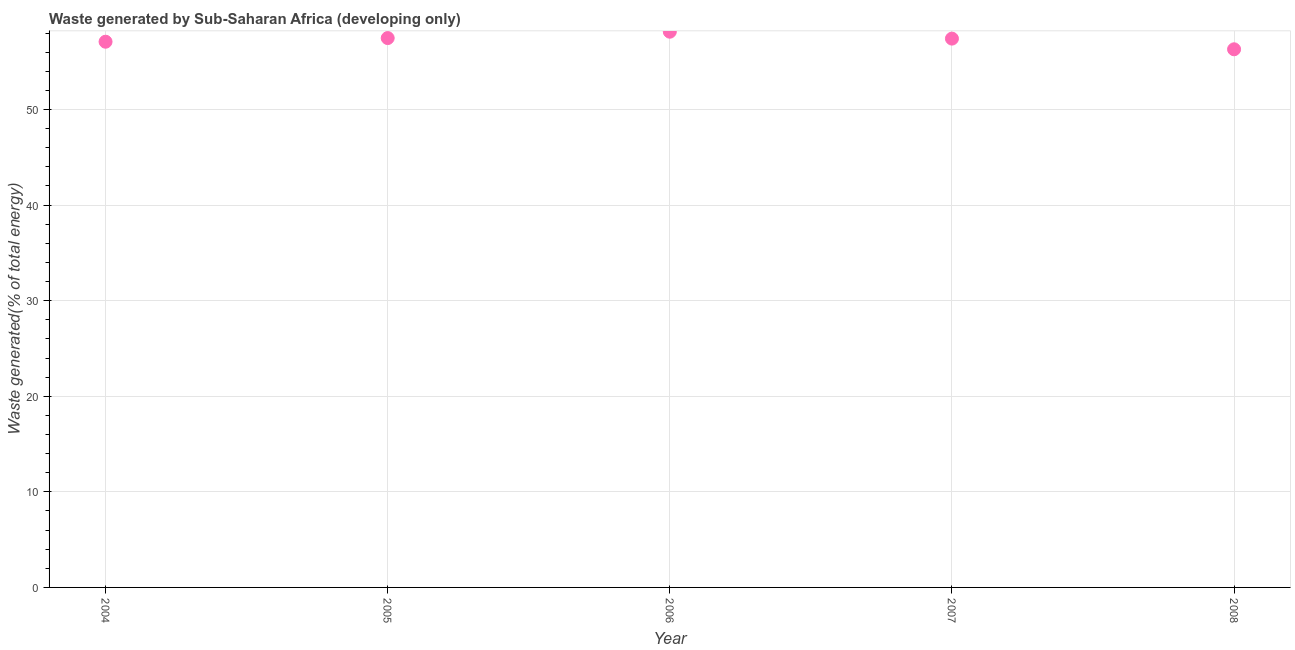What is the amount of waste generated in 2007?
Keep it short and to the point. 57.41. Across all years, what is the maximum amount of waste generated?
Offer a terse response. 58.14. Across all years, what is the minimum amount of waste generated?
Ensure brevity in your answer.  56.3. In which year was the amount of waste generated minimum?
Keep it short and to the point. 2008. What is the sum of the amount of waste generated?
Offer a very short reply. 286.41. What is the difference between the amount of waste generated in 2004 and 2005?
Your response must be concise. -0.38. What is the average amount of waste generated per year?
Keep it short and to the point. 57.28. What is the median amount of waste generated?
Provide a short and direct response. 57.41. In how many years, is the amount of waste generated greater than 20 %?
Give a very brief answer. 5. Do a majority of the years between 2005 and 2007 (inclusive) have amount of waste generated greater than 54 %?
Your response must be concise. Yes. What is the ratio of the amount of waste generated in 2004 to that in 2007?
Make the answer very short. 0.99. Is the amount of waste generated in 2005 less than that in 2006?
Give a very brief answer. Yes. What is the difference between the highest and the second highest amount of waste generated?
Provide a succinct answer. 0.67. What is the difference between the highest and the lowest amount of waste generated?
Your answer should be very brief. 1.84. In how many years, is the amount of waste generated greater than the average amount of waste generated taken over all years?
Provide a short and direct response. 3. Are the values on the major ticks of Y-axis written in scientific E-notation?
Make the answer very short. No. Does the graph contain any zero values?
Your answer should be very brief. No. What is the title of the graph?
Your response must be concise. Waste generated by Sub-Saharan Africa (developing only). What is the label or title of the X-axis?
Offer a very short reply. Year. What is the label or title of the Y-axis?
Offer a terse response. Waste generated(% of total energy). What is the Waste generated(% of total energy) in 2004?
Provide a succinct answer. 57.09. What is the Waste generated(% of total energy) in 2005?
Make the answer very short. 57.47. What is the Waste generated(% of total energy) in 2006?
Offer a terse response. 58.14. What is the Waste generated(% of total energy) in 2007?
Provide a short and direct response. 57.41. What is the Waste generated(% of total energy) in 2008?
Keep it short and to the point. 56.3. What is the difference between the Waste generated(% of total energy) in 2004 and 2005?
Ensure brevity in your answer.  -0.38. What is the difference between the Waste generated(% of total energy) in 2004 and 2006?
Make the answer very short. -1.05. What is the difference between the Waste generated(% of total energy) in 2004 and 2007?
Your answer should be very brief. -0.33. What is the difference between the Waste generated(% of total energy) in 2004 and 2008?
Provide a short and direct response. 0.79. What is the difference between the Waste generated(% of total energy) in 2005 and 2006?
Keep it short and to the point. -0.67. What is the difference between the Waste generated(% of total energy) in 2005 and 2007?
Offer a terse response. 0.06. What is the difference between the Waste generated(% of total energy) in 2005 and 2008?
Your response must be concise. 1.17. What is the difference between the Waste generated(% of total energy) in 2006 and 2007?
Make the answer very short. 0.72. What is the difference between the Waste generated(% of total energy) in 2006 and 2008?
Offer a terse response. 1.84. What is the difference between the Waste generated(% of total energy) in 2007 and 2008?
Your answer should be compact. 1.12. What is the ratio of the Waste generated(% of total energy) in 2004 to that in 2007?
Keep it short and to the point. 0.99. What is the ratio of the Waste generated(% of total energy) in 2005 to that in 2007?
Provide a succinct answer. 1. What is the ratio of the Waste generated(% of total energy) in 2005 to that in 2008?
Keep it short and to the point. 1.02. What is the ratio of the Waste generated(% of total energy) in 2006 to that in 2007?
Ensure brevity in your answer.  1.01. What is the ratio of the Waste generated(% of total energy) in 2006 to that in 2008?
Offer a very short reply. 1.03. What is the ratio of the Waste generated(% of total energy) in 2007 to that in 2008?
Provide a short and direct response. 1.02. 